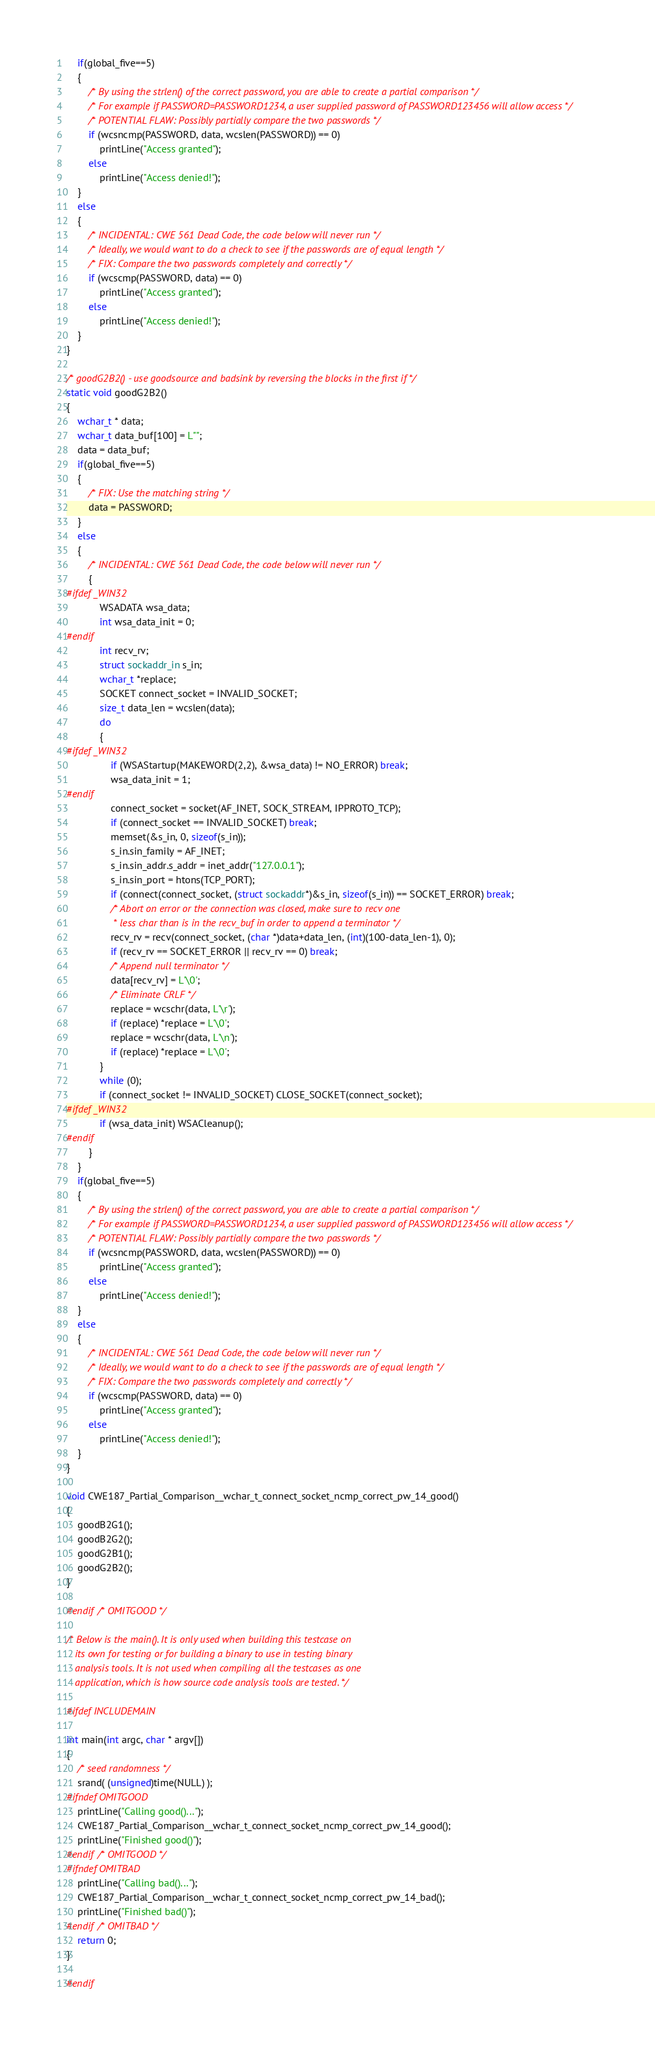Convert code to text. <code><loc_0><loc_0><loc_500><loc_500><_C_>    if(global_five==5)
    {
        /* By using the strlen() of the correct password, you are able to create a partial comparison */
        /* For example if PASSWORD=PASSWORD1234, a user supplied password of PASSWORD123456 will allow access */
        /* POTENTIAL FLAW: Possibly partially compare the two passwords */
        if (wcsncmp(PASSWORD, data, wcslen(PASSWORD)) == 0)
            printLine("Access granted");
        else
            printLine("Access denied!");
    }
    else
    {
        /* INCIDENTAL: CWE 561 Dead Code, the code below will never run */
        /* Ideally, we would want to do a check to see if the passwords are of equal length */
        /* FIX: Compare the two passwords completely and correctly */
        if (wcscmp(PASSWORD, data) == 0)
            printLine("Access granted");
        else
            printLine("Access denied!");
    }
}

/* goodG2B2() - use goodsource and badsink by reversing the blocks in the first if */
static void goodG2B2()
{
    wchar_t * data;
    wchar_t data_buf[100] = L"";
    data = data_buf;
    if(global_five==5)
    {
        /* FIX: Use the matching string */
        data = PASSWORD;
    }
    else
    {
        /* INCIDENTAL: CWE 561 Dead Code, the code below will never run */
        {
#ifdef _WIN32
            WSADATA wsa_data;
            int wsa_data_init = 0;
#endif
            int recv_rv;
            struct sockaddr_in s_in;
            wchar_t *replace;
            SOCKET connect_socket = INVALID_SOCKET;
            size_t data_len = wcslen(data);
            do
            {
#ifdef _WIN32
                if (WSAStartup(MAKEWORD(2,2), &wsa_data) != NO_ERROR) break;
                wsa_data_init = 1;
#endif
                connect_socket = socket(AF_INET, SOCK_STREAM, IPPROTO_TCP);
                if (connect_socket == INVALID_SOCKET) break;
                memset(&s_in, 0, sizeof(s_in));
                s_in.sin_family = AF_INET;
                s_in.sin_addr.s_addr = inet_addr("127.0.0.1");
                s_in.sin_port = htons(TCP_PORT);
                if (connect(connect_socket, (struct sockaddr*)&s_in, sizeof(s_in)) == SOCKET_ERROR) break;
                /* Abort on error or the connection was closed, make sure to recv one
                 * less char than is in the recv_buf in order to append a terminator */
                recv_rv = recv(connect_socket, (char *)data+data_len, (int)(100-data_len-1), 0);
                if (recv_rv == SOCKET_ERROR || recv_rv == 0) break;
                /* Append null terminator */
                data[recv_rv] = L'\0';
                /* Eliminate CRLF */
                replace = wcschr(data, L'\r');
                if (replace) *replace = L'\0';
                replace = wcschr(data, L'\n');
                if (replace) *replace = L'\0';
            }
            while (0);
            if (connect_socket != INVALID_SOCKET) CLOSE_SOCKET(connect_socket);
#ifdef _WIN32
            if (wsa_data_init) WSACleanup();
#endif
        }
    }
    if(global_five==5)
    {
        /* By using the strlen() of the correct password, you are able to create a partial comparison */
        /* For example if PASSWORD=PASSWORD1234, a user supplied password of PASSWORD123456 will allow access */
        /* POTENTIAL FLAW: Possibly partially compare the two passwords */
        if (wcsncmp(PASSWORD, data, wcslen(PASSWORD)) == 0)
            printLine("Access granted");
        else
            printLine("Access denied!");
    }
    else
    {
        /* INCIDENTAL: CWE 561 Dead Code, the code below will never run */
        /* Ideally, we would want to do a check to see if the passwords are of equal length */
        /* FIX: Compare the two passwords completely and correctly */
        if (wcscmp(PASSWORD, data) == 0)
            printLine("Access granted");
        else
            printLine("Access denied!");
    }
}

void CWE187_Partial_Comparison__wchar_t_connect_socket_ncmp_correct_pw_14_good()
{
    goodB2G1();
    goodB2G2();
    goodG2B1();
    goodG2B2();
}

#endif /* OMITGOOD */

/* Below is the main(). It is only used when building this testcase on
   its own for testing or for building a binary to use in testing binary
   analysis tools. It is not used when compiling all the testcases as one
   application, which is how source code analysis tools are tested. */

#ifdef INCLUDEMAIN

int main(int argc, char * argv[])
{
    /* seed randomness */
    srand( (unsigned)time(NULL) );
#ifndef OMITGOOD
    printLine("Calling good()...");
    CWE187_Partial_Comparison__wchar_t_connect_socket_ncmp_correct_pw_14_good();
    printLine("Finished good()");
#endif /* OMITGOOD */
#ifndef OMITBAD
    printLine("Calling bad()...");
    CWE187_Partial_Comparison__wchar_t_connect_socket_ncmp_correct_pw_14_bad();
    printLine("Finished bad()");
#endif /* OMITBAD */
    return 0;
}

#endif
</code> 